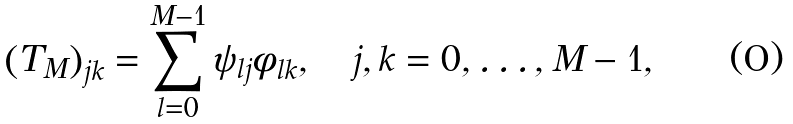<formula> <loc_0><loc_0><loc_500><loc_500>\left ( T _ { M } \right ) _ { j k } = \sum _ { l = 0 } ^ { M - 1 } \psi _ { l j } \phi _ { l k } , \quad j , k = 0 , \dots , M - 1 ,</formula> 